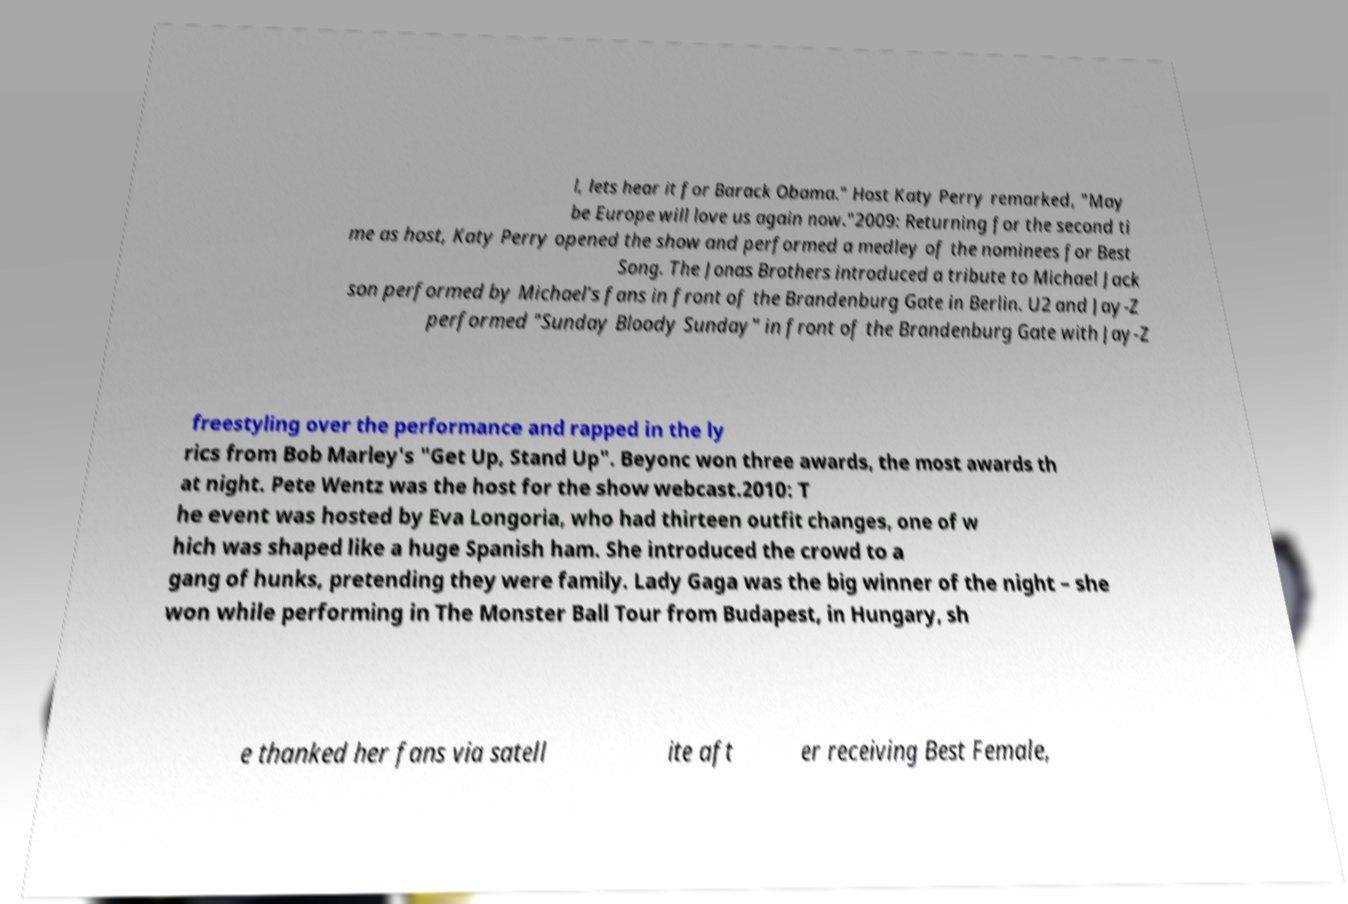Please read and relay the text visible in this image. What does it say? l, lets hear it for Barack Obama." Host Katy Perry remarked, "May be Europe will love us again now."2009: Returning for the second ti me as host, Katy Perry opened the show and performed a medley of the nominees for Best Song. The Jonas Brothers introduced a tribute to Michael Jack son performed by Michael's fans in front of the Brandenburg Gate in Berlin. U2 and Jay-Z performed "Sunday Bloody Sunday" in front of the Brandenburg Gate with Jay-Z freestyling over the performance and rapped in the ly rics from Bob Marley's "Get Up, Stand Up". Beyonc won three awards, the most awards th at night. Pete Wentz was the host for the show webcast.2010: T he event was hosted by Eva Longoria, who had thirteen outfit changes, one of w hich was shaped like a huge Spanish ham. She introduced the crowd to a gang of hunks, pretending they were family. Lady Gaga was the big winner of the night – she won while performing in The Monster Ball Tour from Budapest, in Hungary, sh e thanked her fans via satell ite aft er receiving Best Female, 